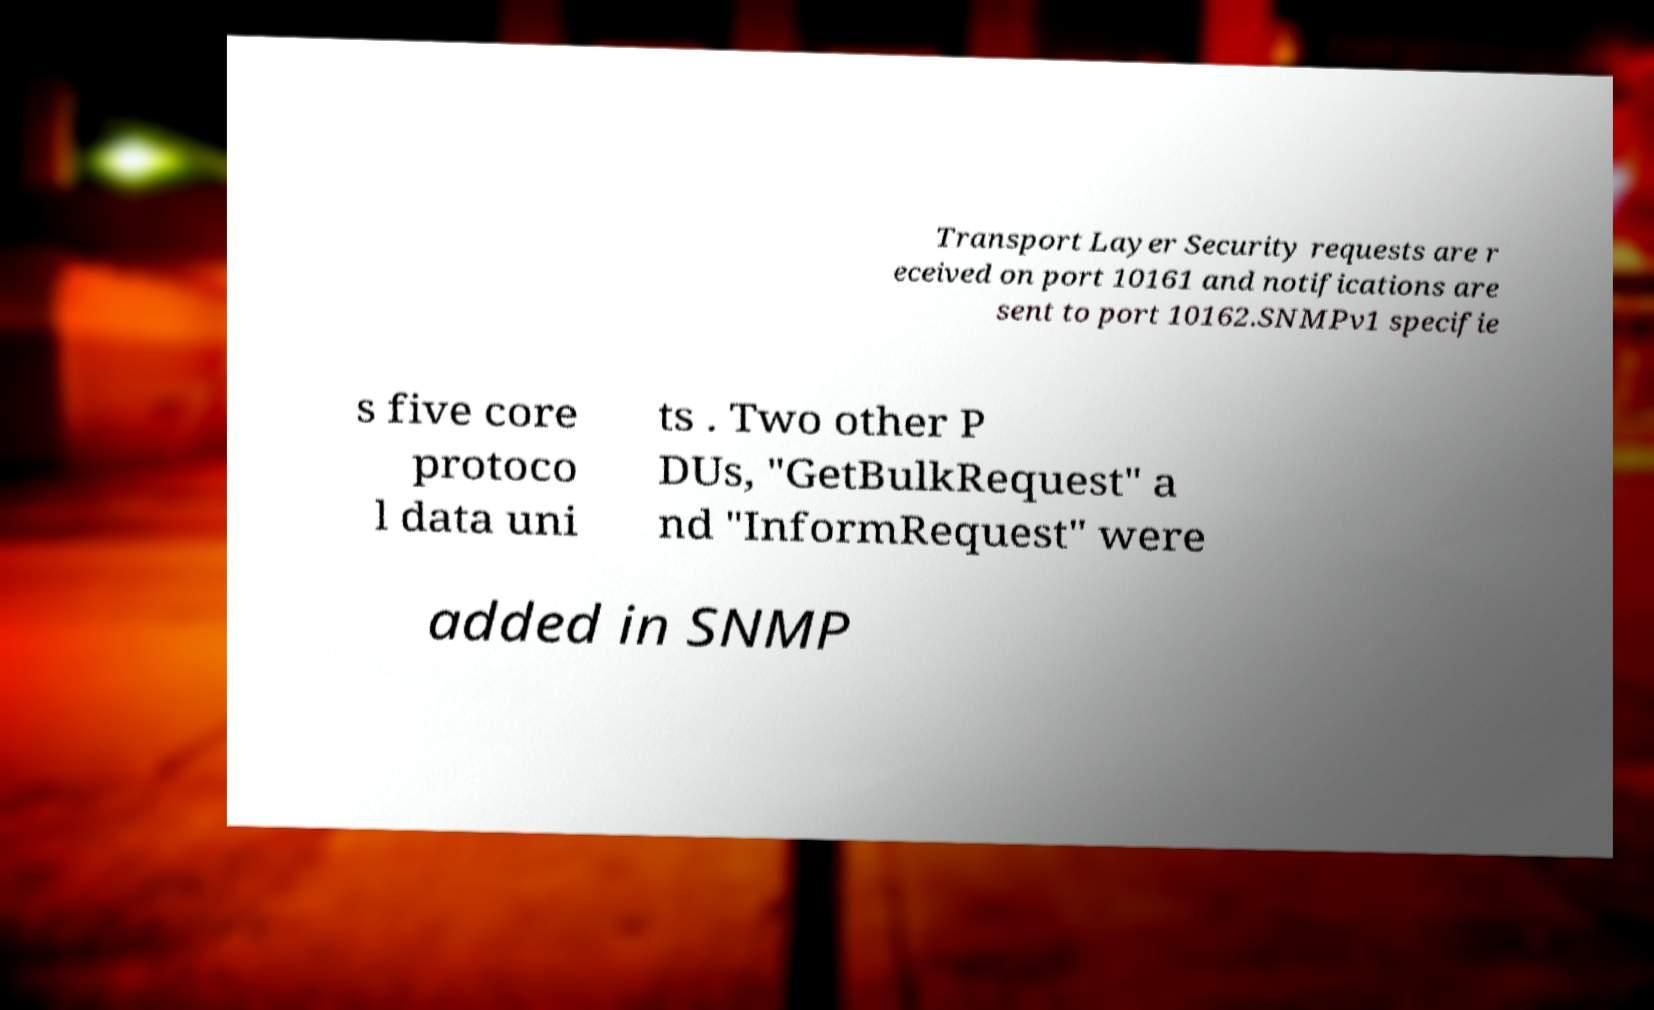For documentation purposes, I need the text within this image transcribed. Could you provide that? Transport Layer Security requests are r eceived on port 10161 and notifications are sent to port 10162.SNMPv1 specifie s five core protoco l data uni ts . Two other P DUs, "GetBulkRequest" a nd "InformRequest" were added in SNMP 